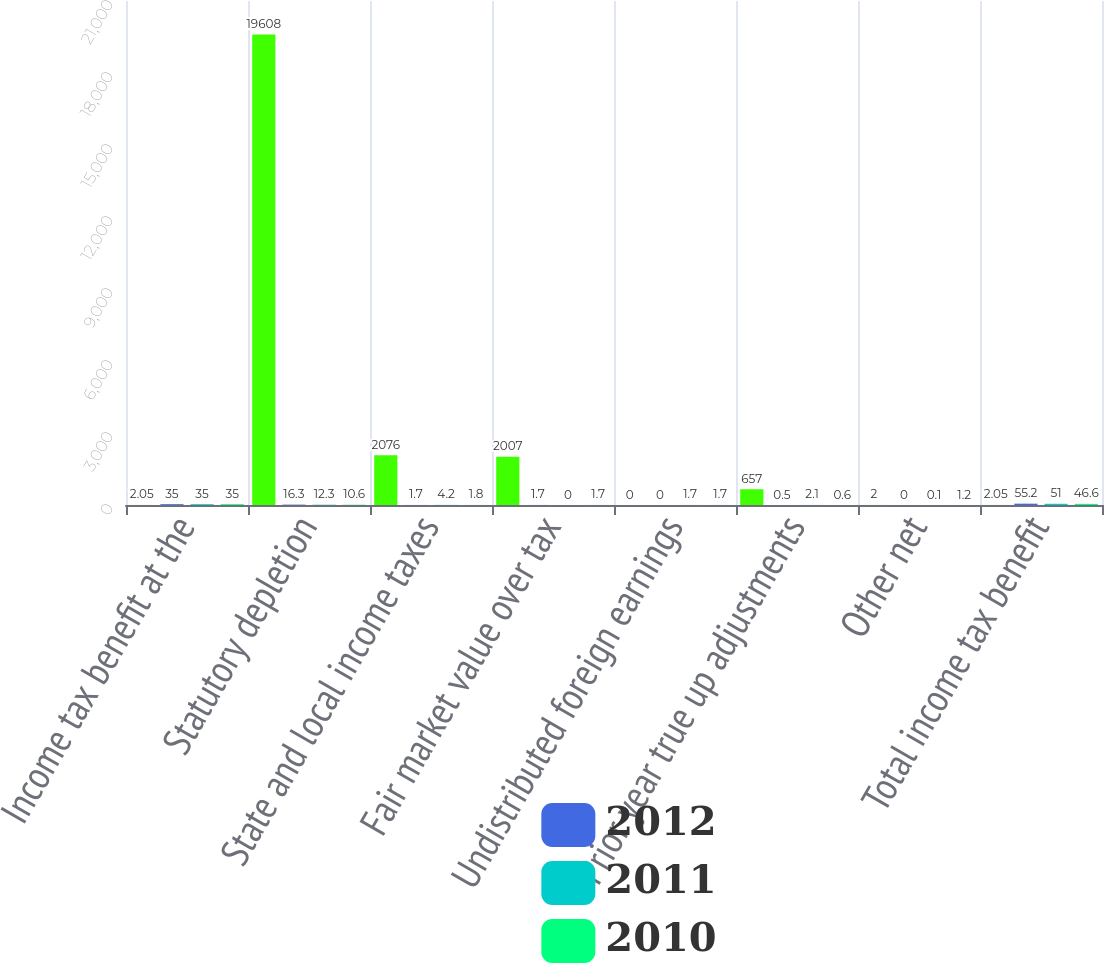Convert chart to OTSL. <chart><loc_0><loc_0><loc_500><loc_500><stacked_bar_chart><ecel><fcel>Income tax benefit at the<fcel>Statutory depletion<fcel>State and local income taxes<fcel>Fair market value over tax<fcel>Undistributed foreign earnings<fcel>Prior year true up adjustments<fcel>Other net<fcel>Total income tax benefit<nl><fcel>nan<fcel>2.05<fcel>19608<fcel>2076<fcel>2007<fcel>0<fcel>657<fcel>2<fcel>2.05<nl><fcel>2012<fcel>35<fcel>16.3<fcel>1.7<fcel>1.7<fcel>0<fcel>0.5<fcel>0<fcel>55.2<nl><fcel>2011<fcel>35<fcel>12.3<fcel>4.2<fcel>0<fcel>1.7<fcel>2.1<fcel>0.1<fcel>51<nl><fcel>2010<fcel>35<fcel>10.6<fcel>1.8<fcel>1.7<fcel>1.7<fcel>0.6<fcel>1.2<fcel>46.6<nl></chart> 